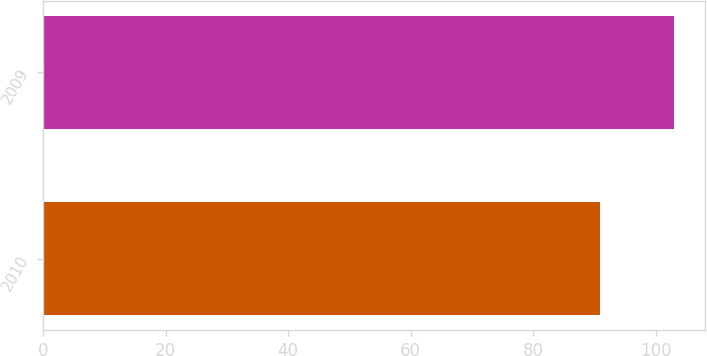<chart> <loc_0><loc_0><loc_500><loc_500><bar_chart><fcel>2010<fcel>2009<nl><fcel>91<fcel>103<nl></chart> 